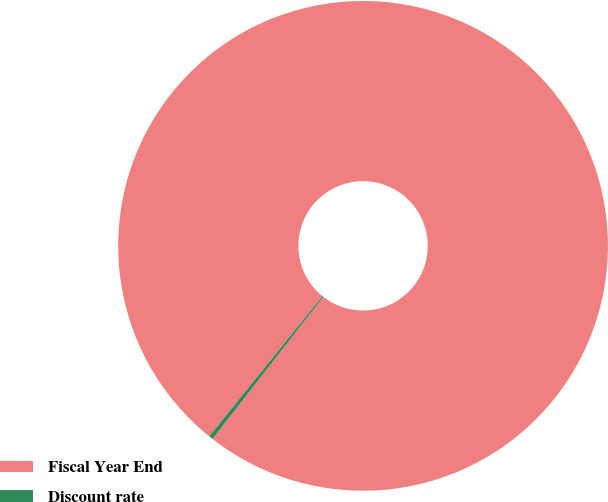Convert chart to OTSL. <chart><loc_0><loc_0><loc_500><loc_500><pie_chart><fcel>Fiscal Year End<fcel>Discount rate<nl><fcel>99.72%<fcel>0.28%<nl></chart> 